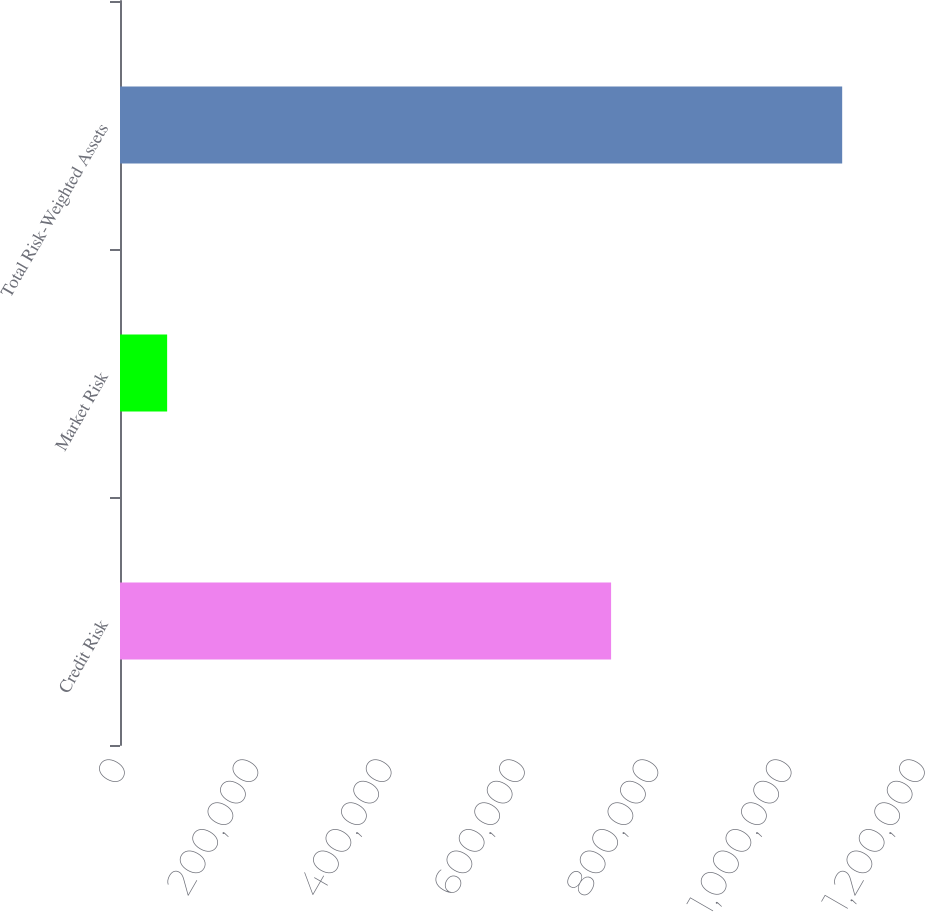Convert chart. <chart><loc_0><loc_0><loc_500><loc_500><bar_chart><fcel>Credit Risk<fcel>Market Risk<fcel>Total Risk-Weighted Assets<nl><fcel>736641<fcel>70715<fcel>1.08328e+06<nl></chart> 